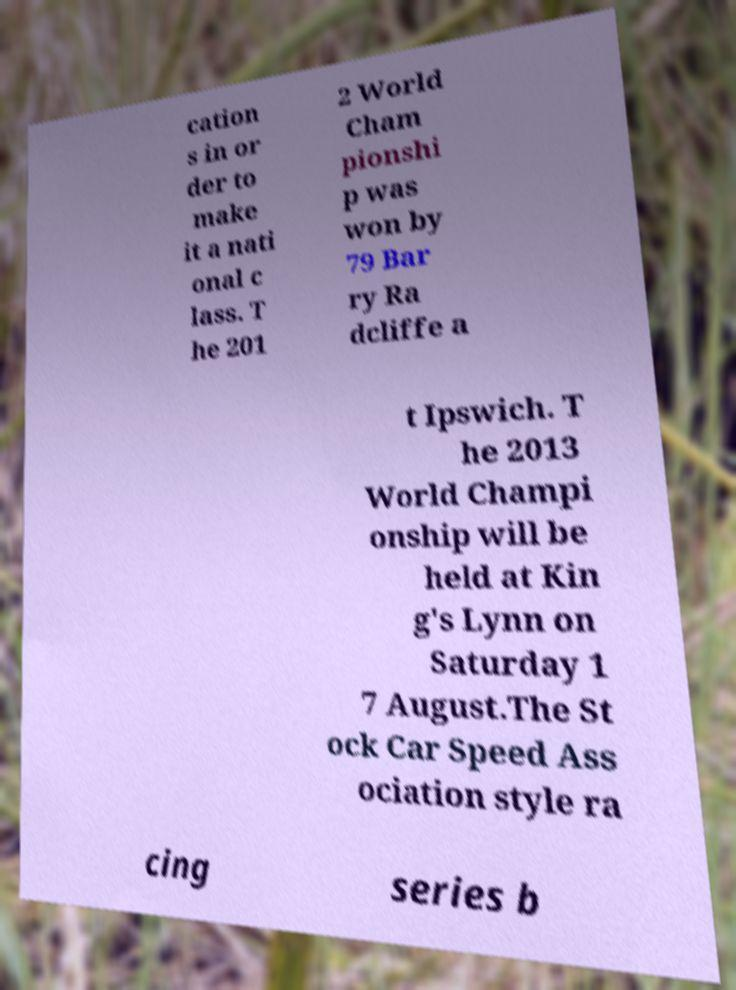Can you read and provide the text displayed in the image?This photo seems to have some interesting text. Can you extract and type it out for me? cation s in or der to make it a nati onal c lass. T he 201 2 World Cham pionshi p was won by 79 Bar ry Ra dcliffe a t Ipswich. T he 2013 World Champi onship will be held at Kin g's Lynn on Saturday 1 7 August.The St ock Car Speed Ass ociation style ra cing series b 